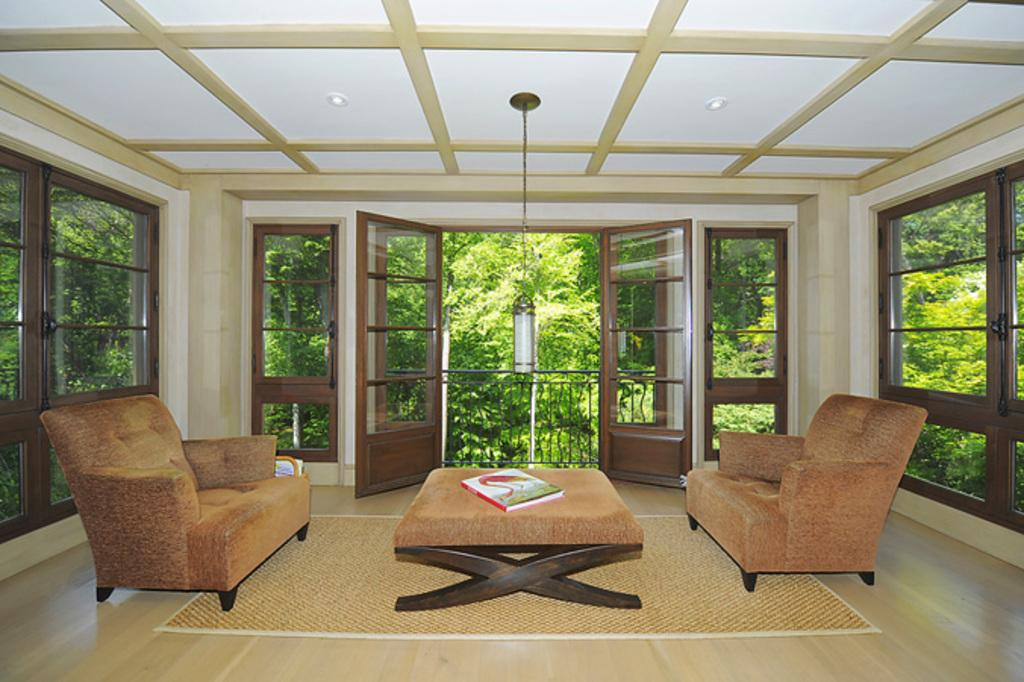What type of furniture is present in the image? There is a sofa in the image. Is there any additional furniture or decorative items in the image? Yes, there is a sofa table in the image. What type of flooring is visible in the image? There is a carpet in the image. What architectural feature can be seen in the image? There is a balcony in the image. What type of fencing is present in the image? There is iron fencing in the image. What can be seen outside the room in the image? Trees are visible outside the room in the image. What type of cabbage is being used as a decoration on the sofa table in the image? There is no cabbage present in the image, let alone being used as a decoration on the sofa table. 